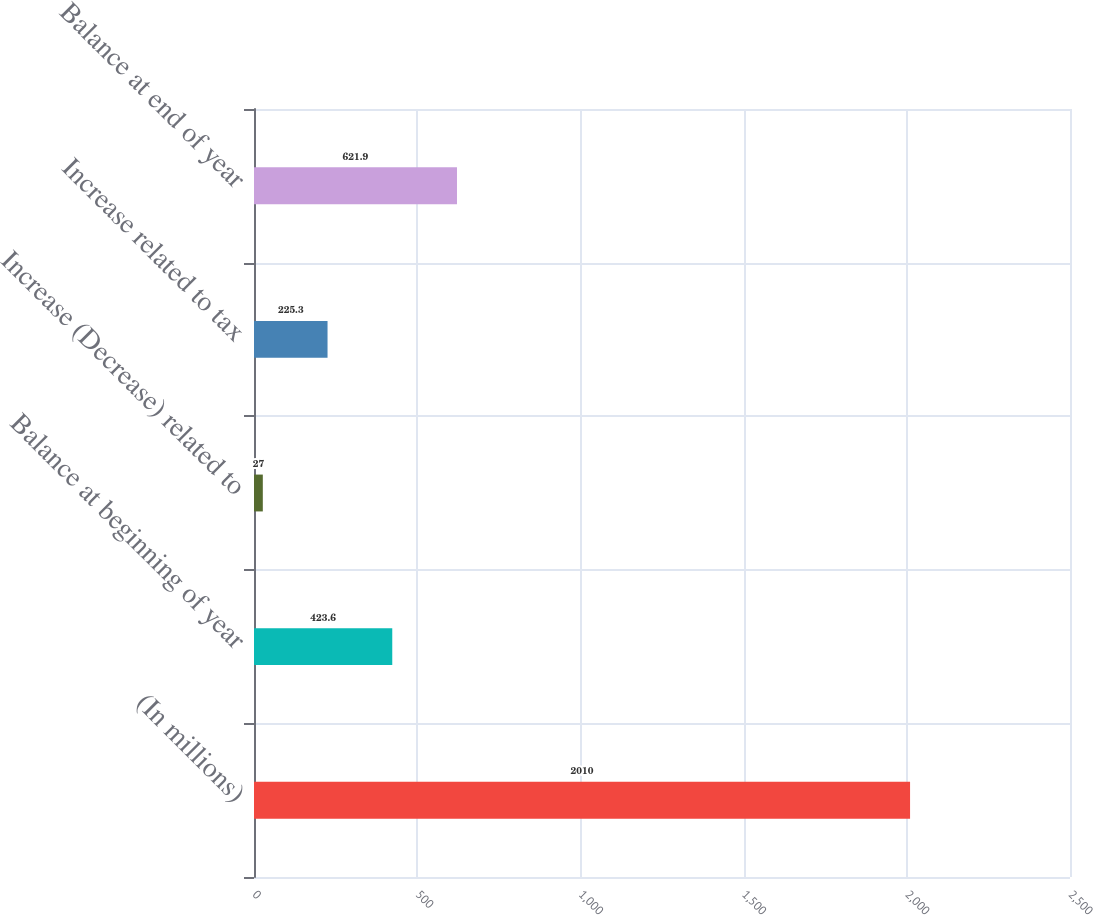<chart> <loc_0><loc_0><loc_500><loc_500><bar_chart><fcel>(In millions)<fcel>Balance at beginning of year<fcel>Increase (Decrease) related to<fcel>Increase related to tax<fcel>Balance at end of year<nl><fcel>2010<fcel>423.6<fcel>27<fcel>225.3<fcel>621.9<nl></chart> 